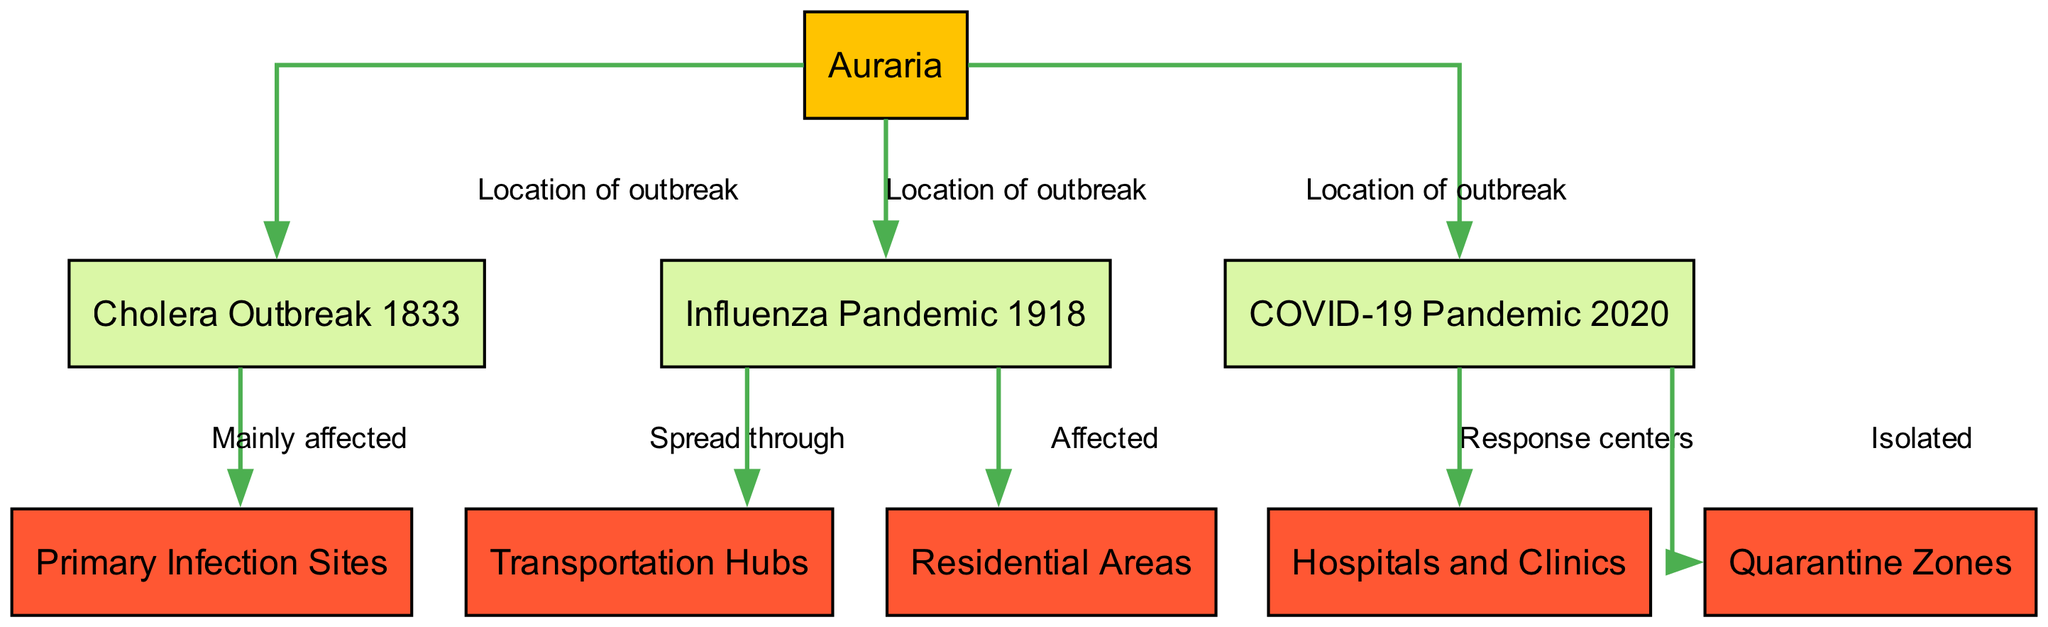What are the three historical epidemics shown in the diagram? The diagram includes three historical events: Cholera Outbreak 1833, Influenza Pandemic 1918, and COVID-19 Pandemic 2020. These are specifically mentioned as nodes representing significant epidemics in Auraria.
Answer: Cholera Outbreak 1833, Influenza Pandemic 1918, COVID-19 Pandemic 2020 How many nodes are categorized under 'category'? There are five nodes categorized under 'category', which includes Primary Infection Sites, Hospitals and Clinics, Quarantine Zones, Transportation Hubs, and Residential Areas. Counting these yields a total of five.
Answer: 5 Which outbreak primarily affected the 'Primary Infection Sites'? The Cholera Outbreak 1833 primarily affected the 'Primary Infection Sites,' as indicated by the relationship between the two nodes in the diagram.
Answer: Cholera Outbreak 1833 Which event's spread was associated with 'Transportation Hubs'? The Influenza Pandemic 1918 is associated with 'Transportation Hubs,' suggesting that this mode of transport facilitated the spread of the influenza virus during that time.
Answer: Influenza Pandemic 1918 What were the two response centers during the COVID-19 Pandemic? The response centers during the COVID-19 Pandemic were Hospitals and Clinics, as depicted in the diagram, which highlights the role of these facilities in addressing the health crisis.
Answer: Hospitals and Clinics How many edges exist between the nodes associated with historical events and categories? There are four edges that connect the historical events to the categories. Counting them shows direct relationships from each event to specific categories affected or involved during the epidemics.
Answer: 4 What is the relationship between the COVID-19 Pandemic and Quarantine Zones? The diagram indicates that during the COVID-19 Pandemic 2020, people were 'Isolated' in Quarantine Zones, demonstrating an impactful measure taken in response to the outbreak.
Answer: Isolated Which two historical events are shown as having a location of outbreak in Auraria? Cholera Outbreak 1833 and Influenza Pandemic 1918 are both indicated to have a location of outbreak in Auraria, as shown by their connection to the Auraria node in the diagram.
Answer: Cholera Outbreak 1833, Influenza Pandemic 1918 